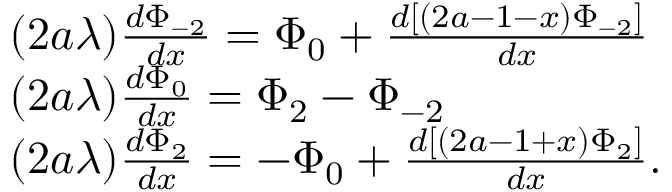Convert formula to latex. <formula><loc_0><loc_0><loc_500><loc_500>\begin{array} { r l } & { ( 2 a \lambda ) \frac { d \Phi _ { - 2 } } { d x } = \Phi _ { 0 } + \frac { d \left [ ( 2 a - 1 - x ) \Phi _ { - 2 } \right ] } { d x } } \\ & { ( 2 a \lambda ) \frac { d \Phi _ { 0 } } { d x } = \Phi _ { 2 } - \Phi _ { - 2 } } \\ & { ( 2 a \lambda ) \frac { d \Phi _ { 2 } } { d x } = - \Phi _ { 0 } + \frac { d \left [ ( 2 a - 1 + x ) \Phi _ { 2 } \right ] } { d x } . } \end{array}</formula> 